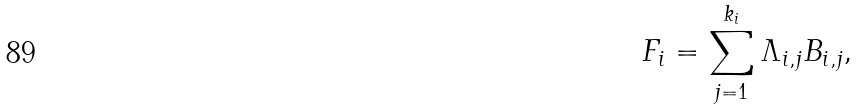Convert formula to latex. <formula><loc_0><loc_0><loc_500><loc_500>F _ { i } = \sum _ { j = 1 } ^ { k _ { i } } \Lambda _ { i , j } B _ { i , j } ,</formula> 